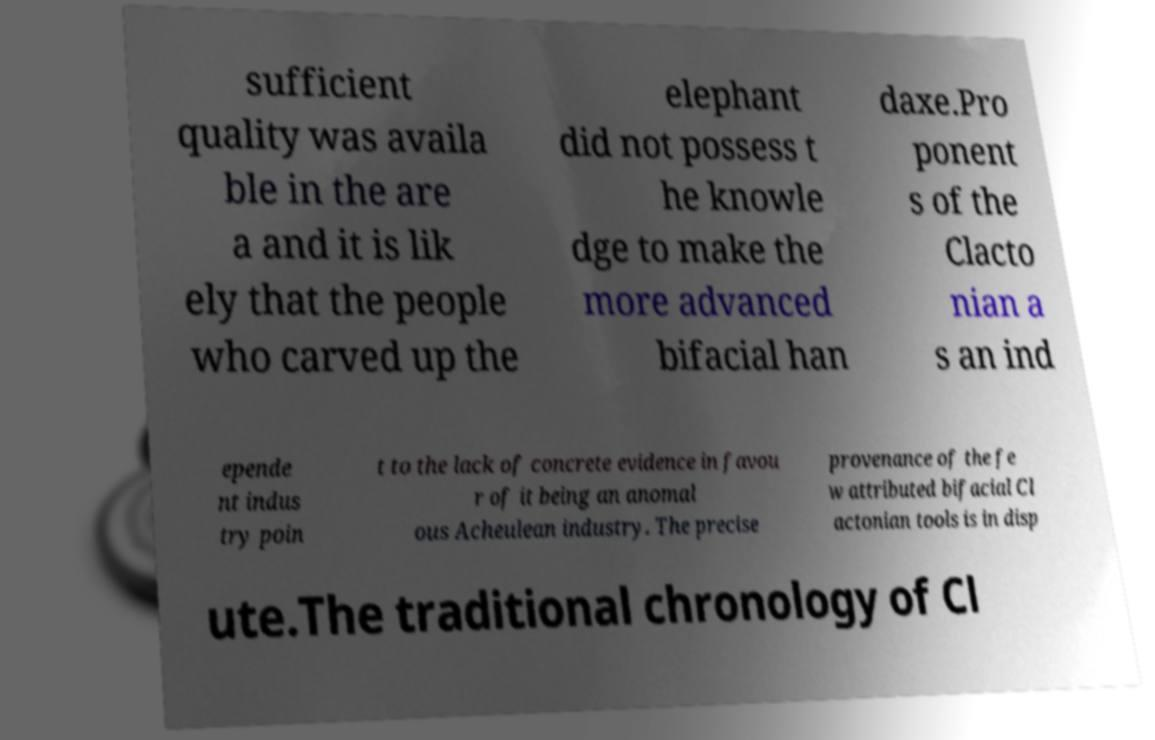For documentation purposes, I need the text within this image transcribed. Could you provide that? sufficient quality was availa ble in the are a and it is lik ely that the people who carved up the elephant did not possess t he knowle dge to make the more advanced bifacial han daxe.Pro ponent s of the Clacto nian a s an ind epende nt indus try poin t to the lack of concrete evidence in favou r of it being an anomal ous Acheulean industry. The precise provenance of the fe w attributed bifacial Cl actonian tools is in disp ute.The traditional chronology of Cl 